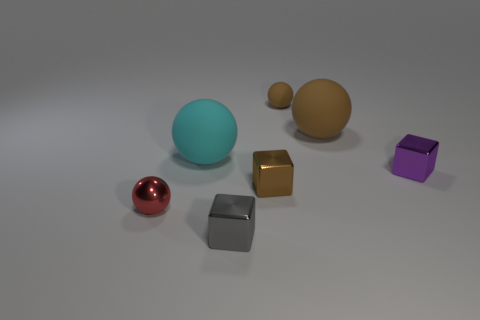Subtract all large brown matte balls. How many balls are left? 3 Subtract all blue blocks. How many brown spheres are left? 2 Add 1 purple cylinders. How many objects exist? 8 Subtract all cyan balls. How many balls are left? 3 Subtract 1 blocks. How many blocks are left? 2 Subtract 0 blue blocks. How many objects are left? 7 Subtract all cubes. How many objects are left? 4 Subtract all green spheres. Subtract all yellow cubes. How many spheres are left? 4 Subtract all big blue matte objects. Subtract all red metal objects. How many objects are left? 6 Add 2 gray cubes. How many gray cubes are left? 3 